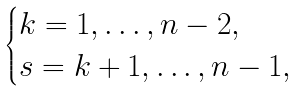Convert formula to latex. <formula><loc_0><loc_0><loc_500><loc_500>\begin{cases} k = 1 , \dots , n - 2 , \\ s = k + 1 , \dots , n - 1 , \end{cases}</formula> 